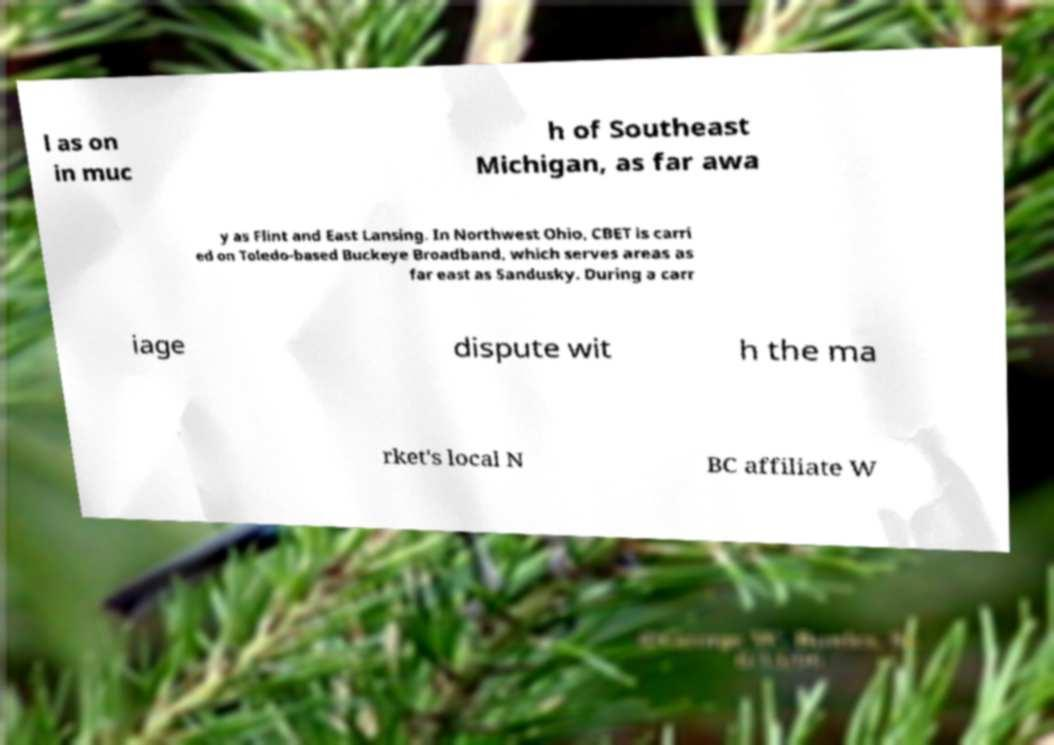For documentation purposes, I need the text within this image transcribed. Could you provide that? l as on in muc h of Southeast Michigan, as far awa y as Flint and East Lansing. In Northwest Ohio, CBET is carri ed on Toledo-based Buckeye Broadband, which serves areas as far east as Sandusky. During a carr iage dispute wit h the ma rket's local N BC affiliate W 